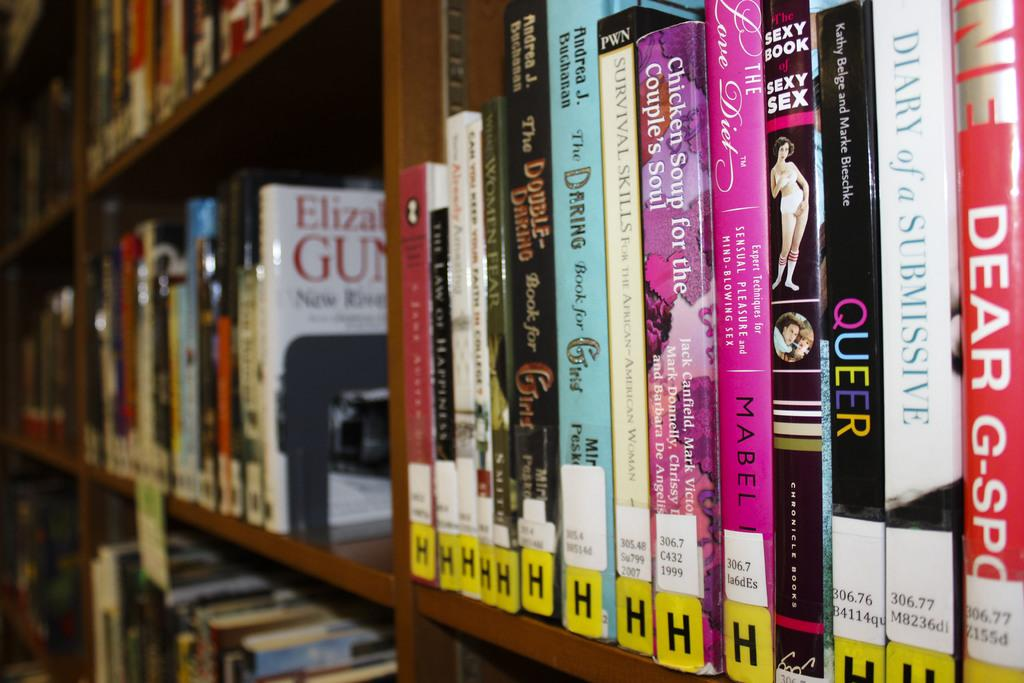<image>
Provide a brief description of the given image. Several books are lined up on a library book shelf, all pertaining to intimacy, love, and couples. 